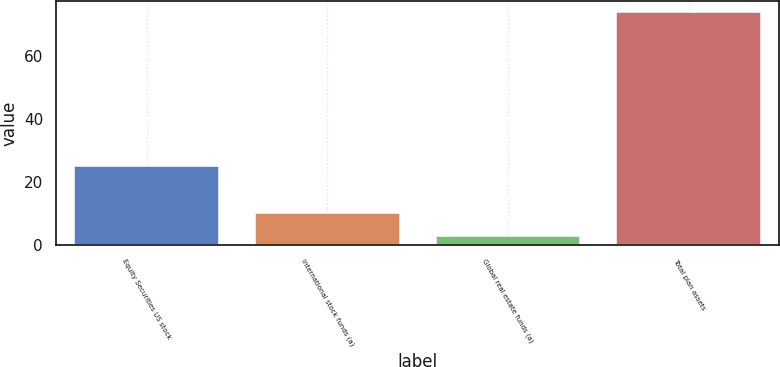<chart> <loc_0><loc_0><loc_500><loc_500><bar_chart><fcel>Equity Securities US stock<fcel>International stock funds (a)<fcel>Global real estate funds (a)<fcel>Total plan assets<nl><fcel>25<fcel>10.1<fcel>3<fcel>74<nl></chart> 